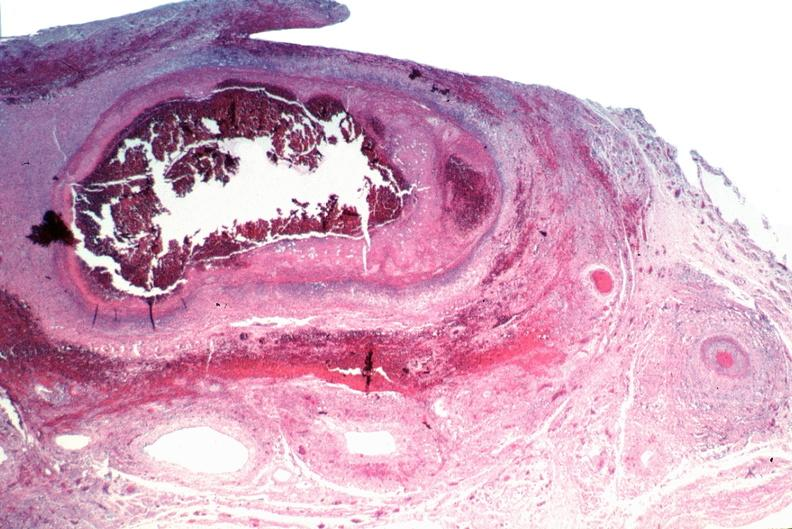what is present?
Answer the question using a single word or phrase. Cardiovascular 